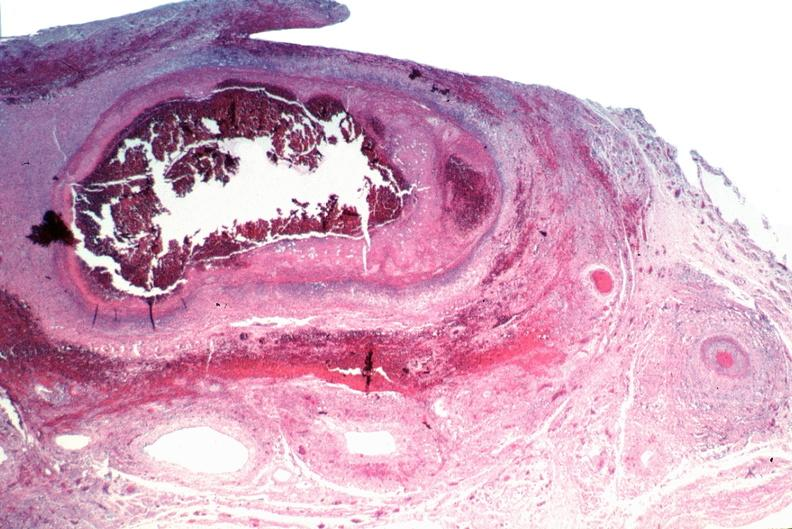what is present?
Answer the question using a single word or phrase. Cardiovascular 